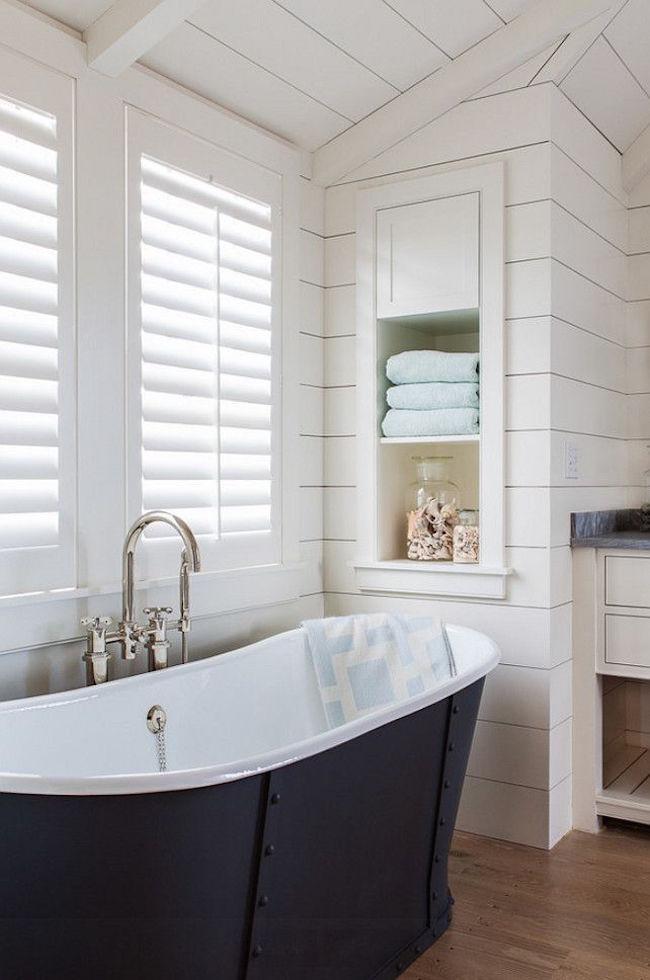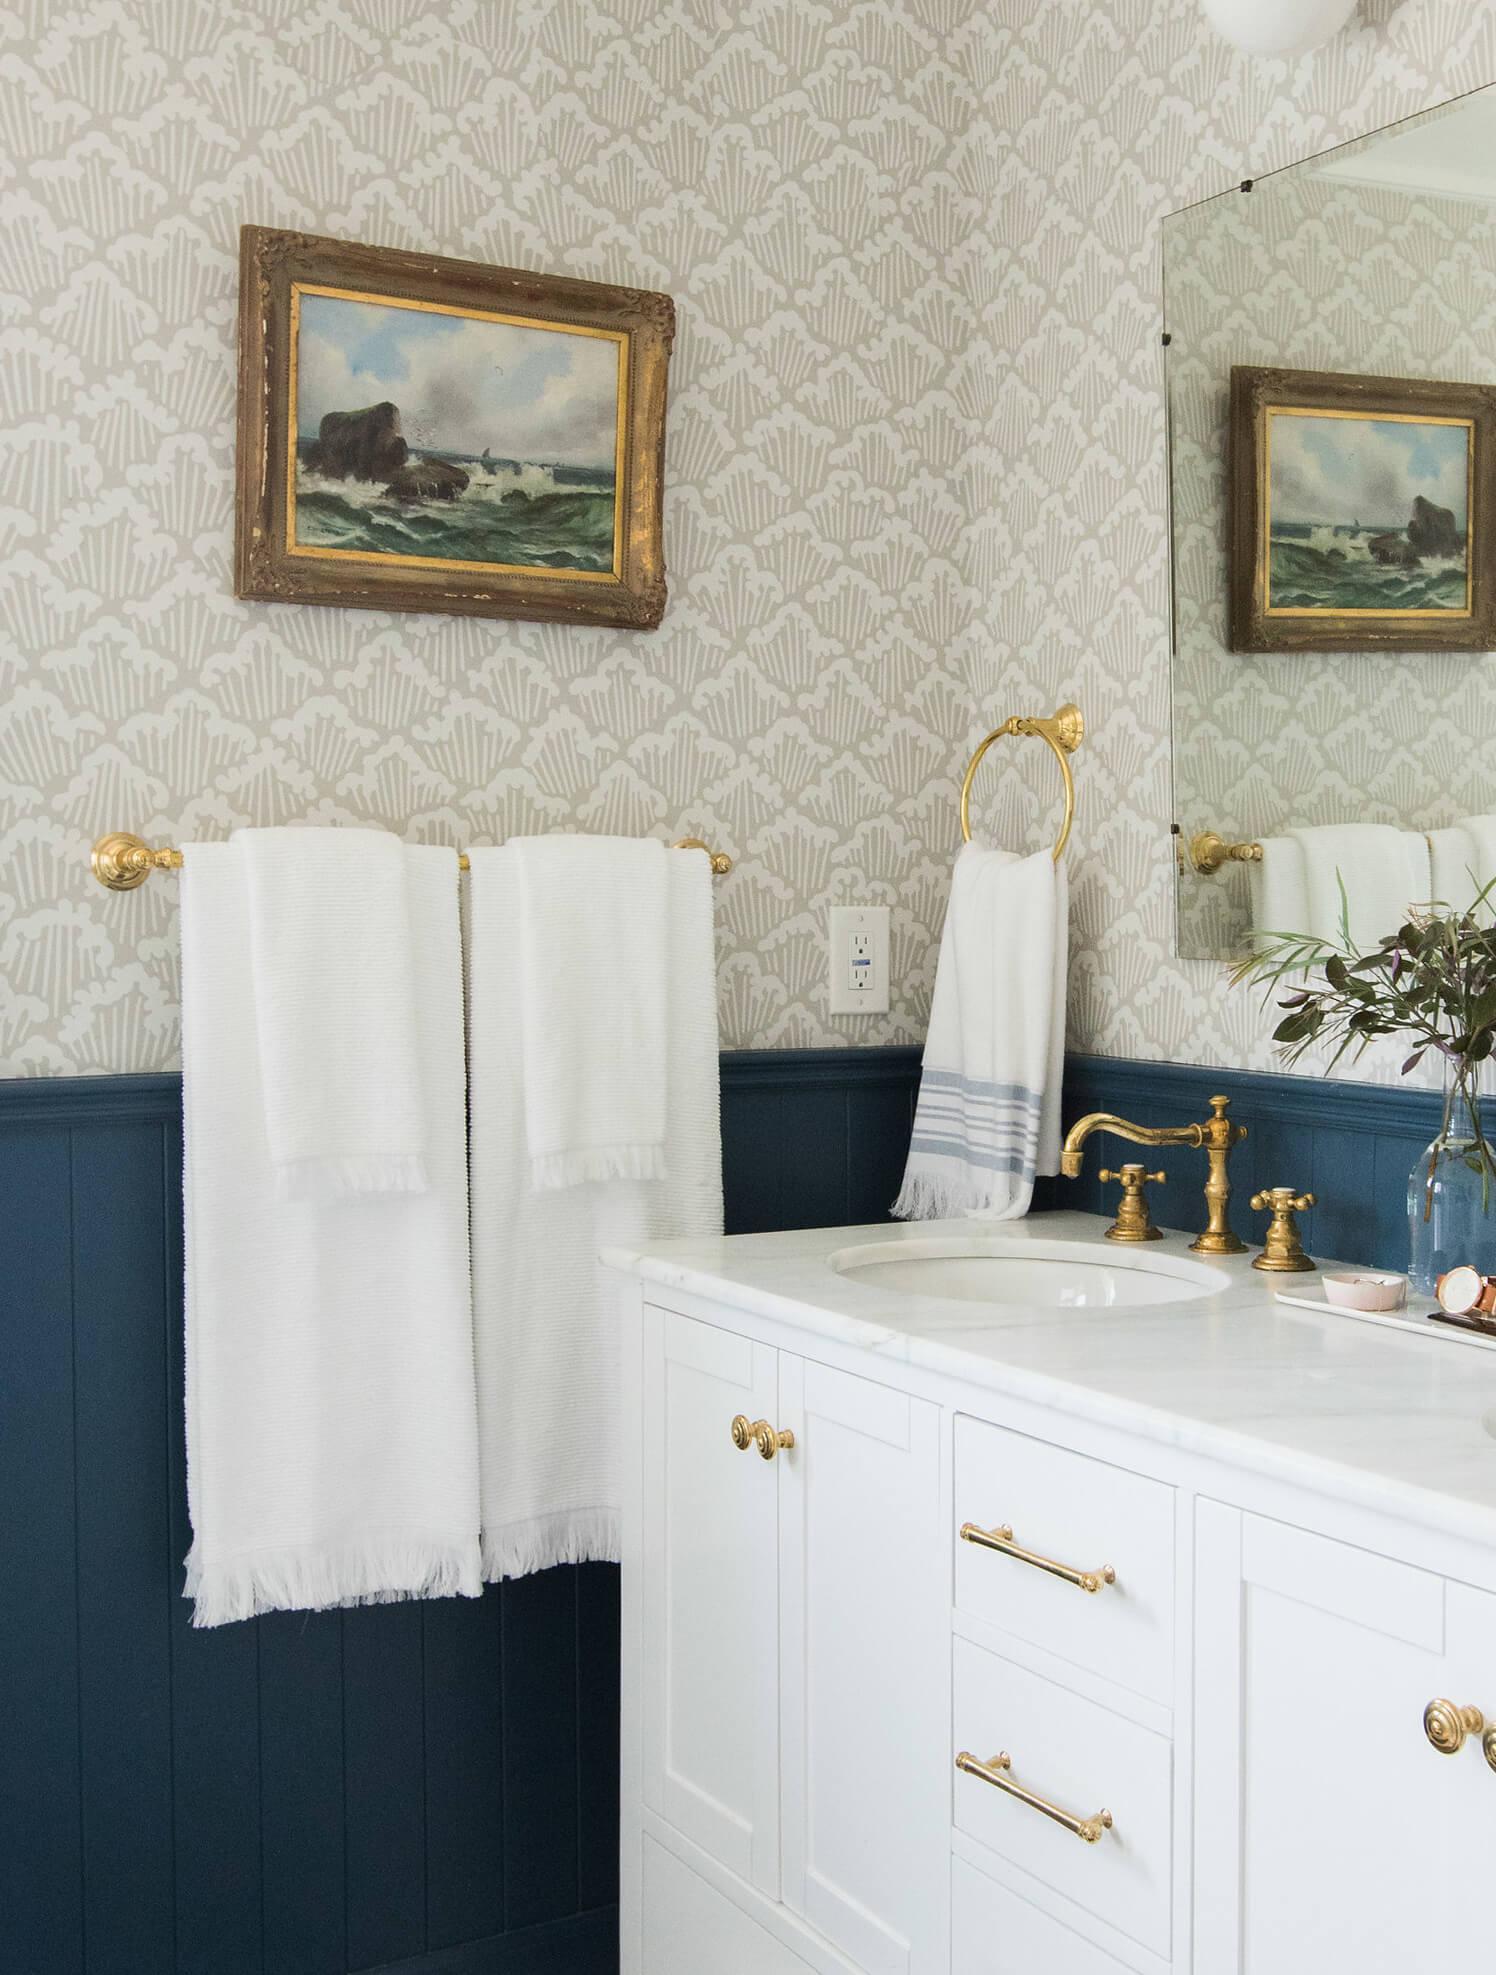The first image is the image on the left, the second image is the image on the right. Evaluate the accuracy of this statement regarding the images: "There are towels hanging on racks.". Is it true? Answer yes or no. Yes. The first image is the image on the left, the second image is the image on the right. For the images displayed, is the sentence "A light colored towel is draped over the side of a freestanding tub." factually correct? Answer yes or no. Yes. 